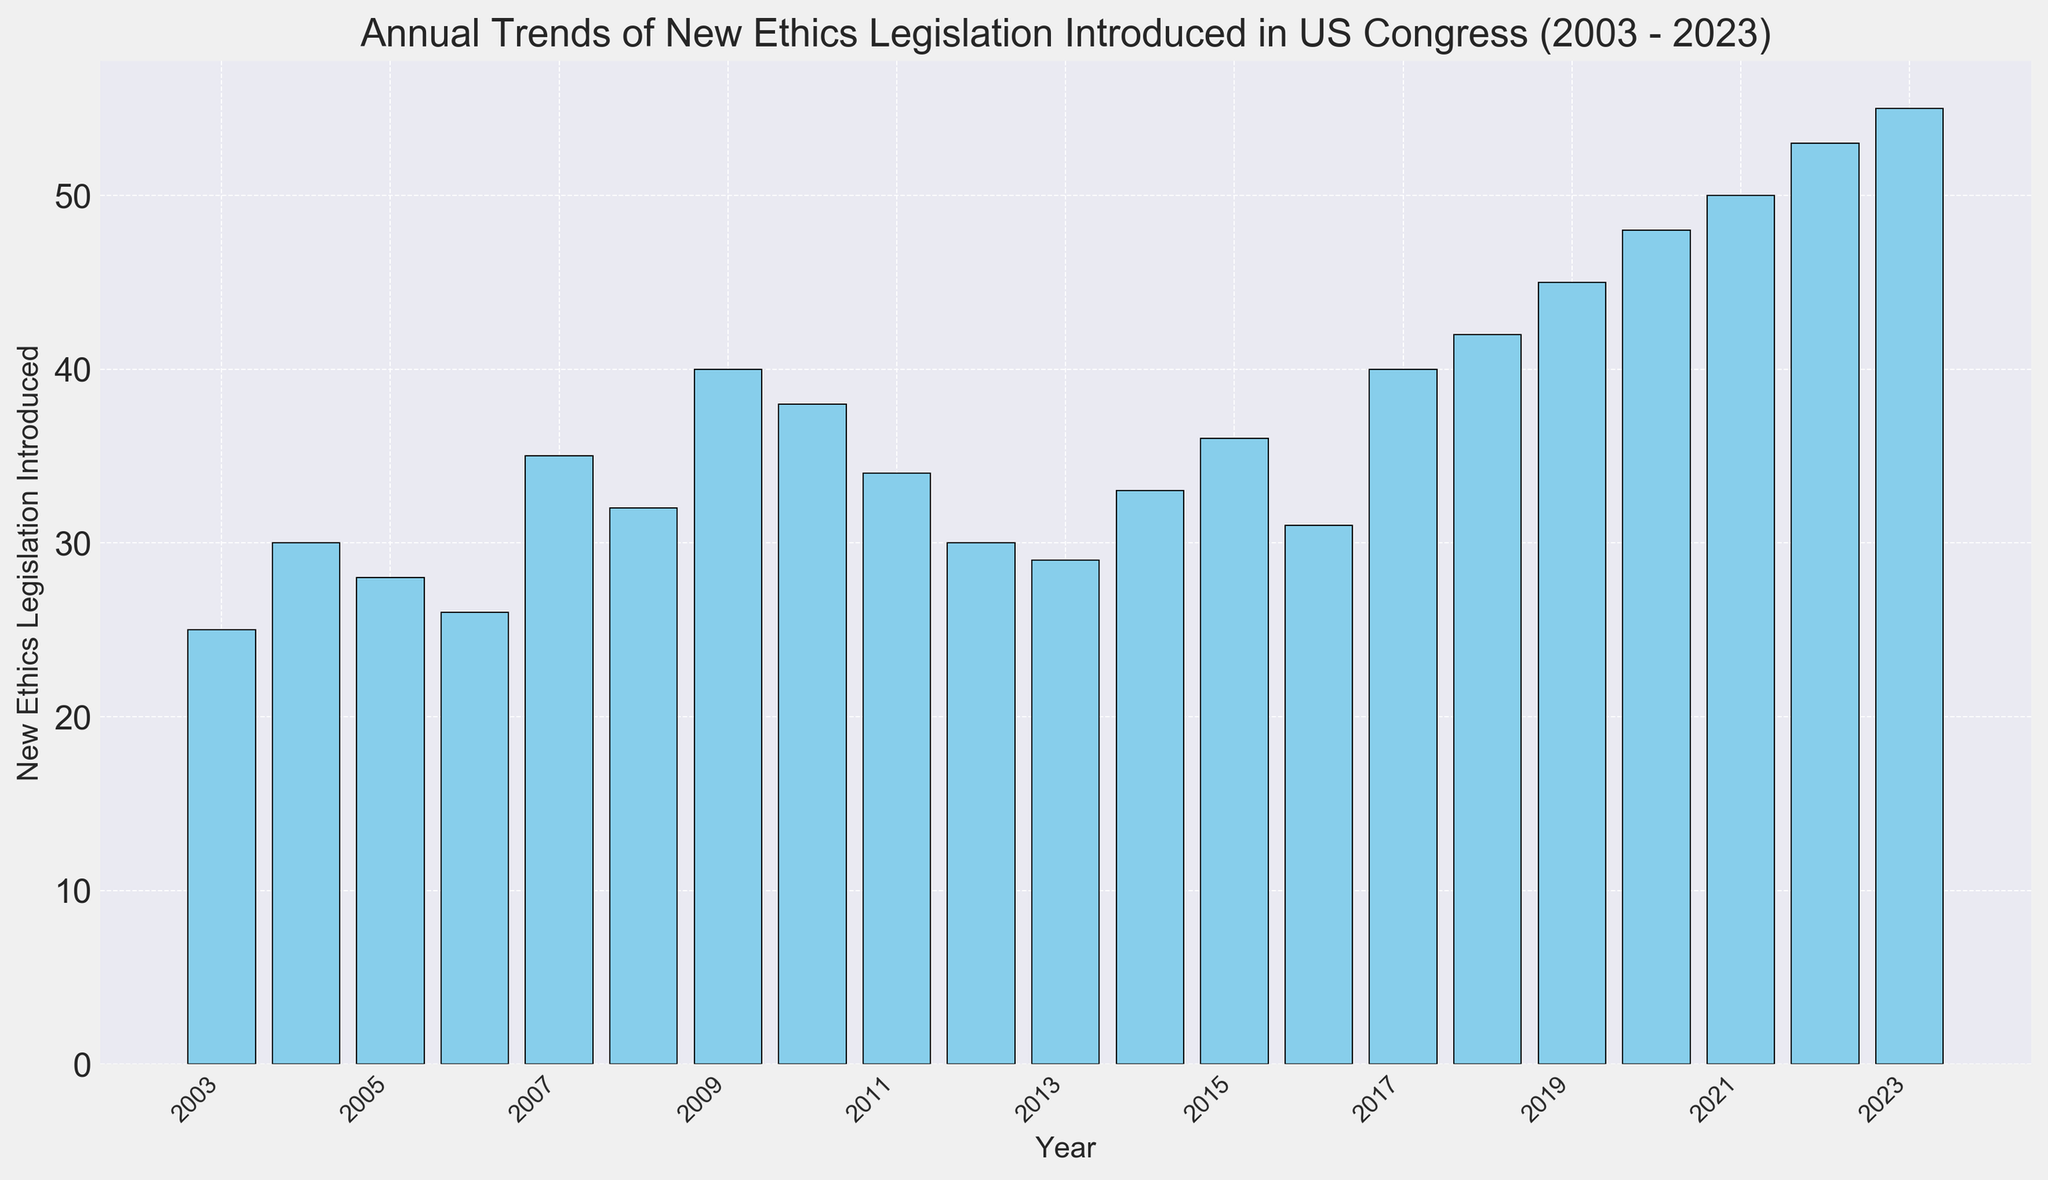When was the highest number of new ethics legislation introduced? By examining the bar heights, the tallest bar represents the year 2023, indicating the highest number of new ethics legislation.
Answer: 2023 How many laws were introduced in 2007? Look at the bar corresponding to the year 2007 and read its height value, which is 35.
Answer: 35 What's the difference in the number of new ethics legislation introduced between 2020 and 2023? Identify the values for 2020 (48) and 2023 (55), and subtract 48 from 55.
Answer: 7 Which year had more new ethics legislation: 2008 or 2018? Compare the heights of the bars corresponding to 2008 and 2018. The bar for 2018 is taller.
Answer: 2018 What's the total number of new ethics legislations introduced from 2003 to 2007? Sum the values for the years 2003 (25), 2004 (30), 2005 (28), 2006 (26), and 2007 (35). Total is 25 + 30 + 28 + 26 + 35 = 144.
Answer: 144 Which two consecutive years have the greatest increase in the number of new ethics legislation introduced? Compare the differences between each consecutive year and identify the period with the largest increase. From 2021 to 2022 there is an increase from 50 to 53 (+3), then from 2022 to 2023 the increase is 5 (from 53 to 55), which is the greatest.
Answer: 2022 to 2023 What's the average number of new ethics legislations introduced from 2019 to 2023? Sum the values for 2019 (45), 2020 (48), 2021 (50), 2022 (53), and 2023 (55), then divide by 5. Total is 251, so the average is 251/5 = 50.2.
Answer: 50.2 